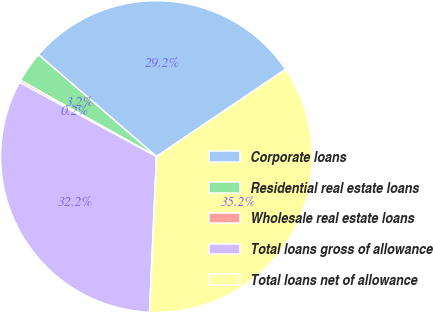Convert chart. <chart><loc_0><loc_0><loc_500><loc_500><pie_chart><fcel>Corporate loans<fcel>Residential real estate loans<fcel>Wholesale real estate loans<fcel>Total loans gross of allowance<fcel>Total loans net of allowance<nl><fcel>29.21%<fcel>3.21%<fcel>0.23%<fcel>32.19%<fcel>35.16%<nl></chart> 